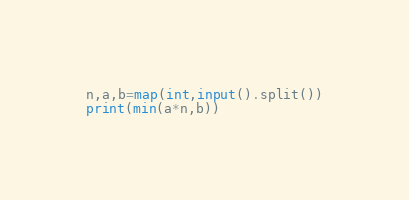Convert code to text. <code><loc_0><loc_0><loc_500><loc_500><_Python_>n,a,b=map(int,input().split())
print(min(a*n,b))</code> 